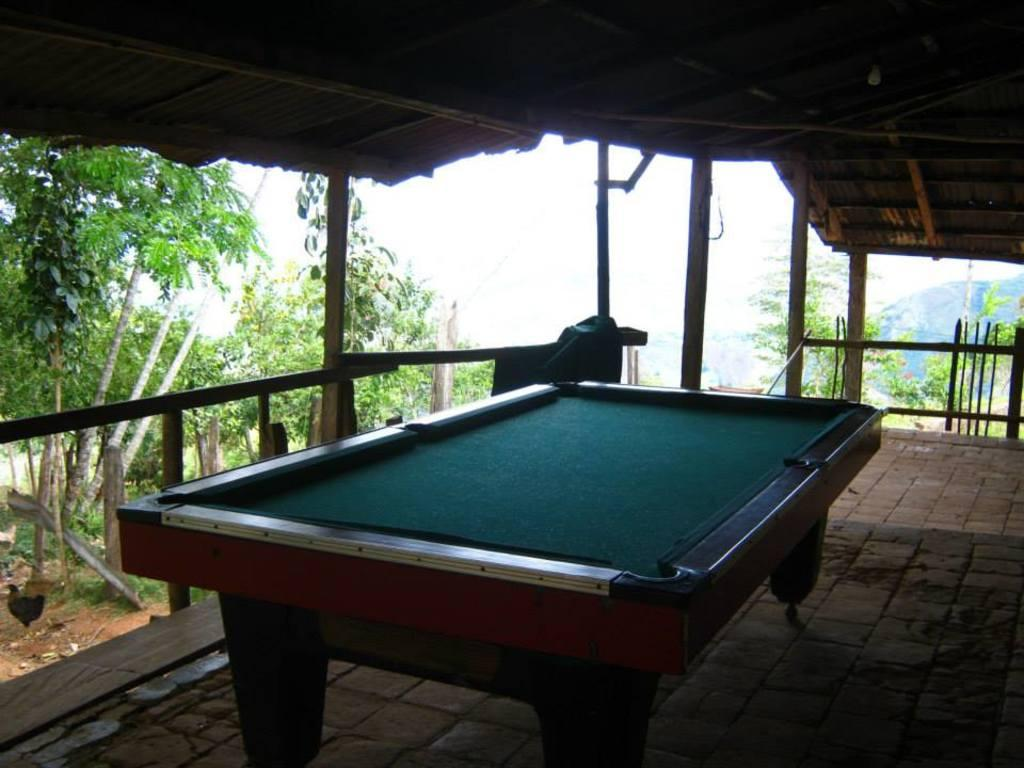What is the main object in the image? There is a billiard board in the image. What can be seen on the ground in the image? There are trees on the ground in the image. How many feet does your aunt have in the image? There is no mention of an aunt or feet in the image, so this question cannot be answered. 